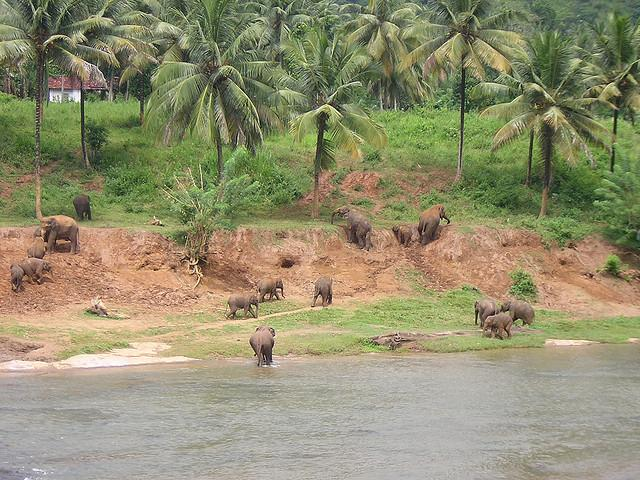What is a unique feature of these animals?

Choices:
A) quills
B) gills
C) neck
D) trunk trunk 